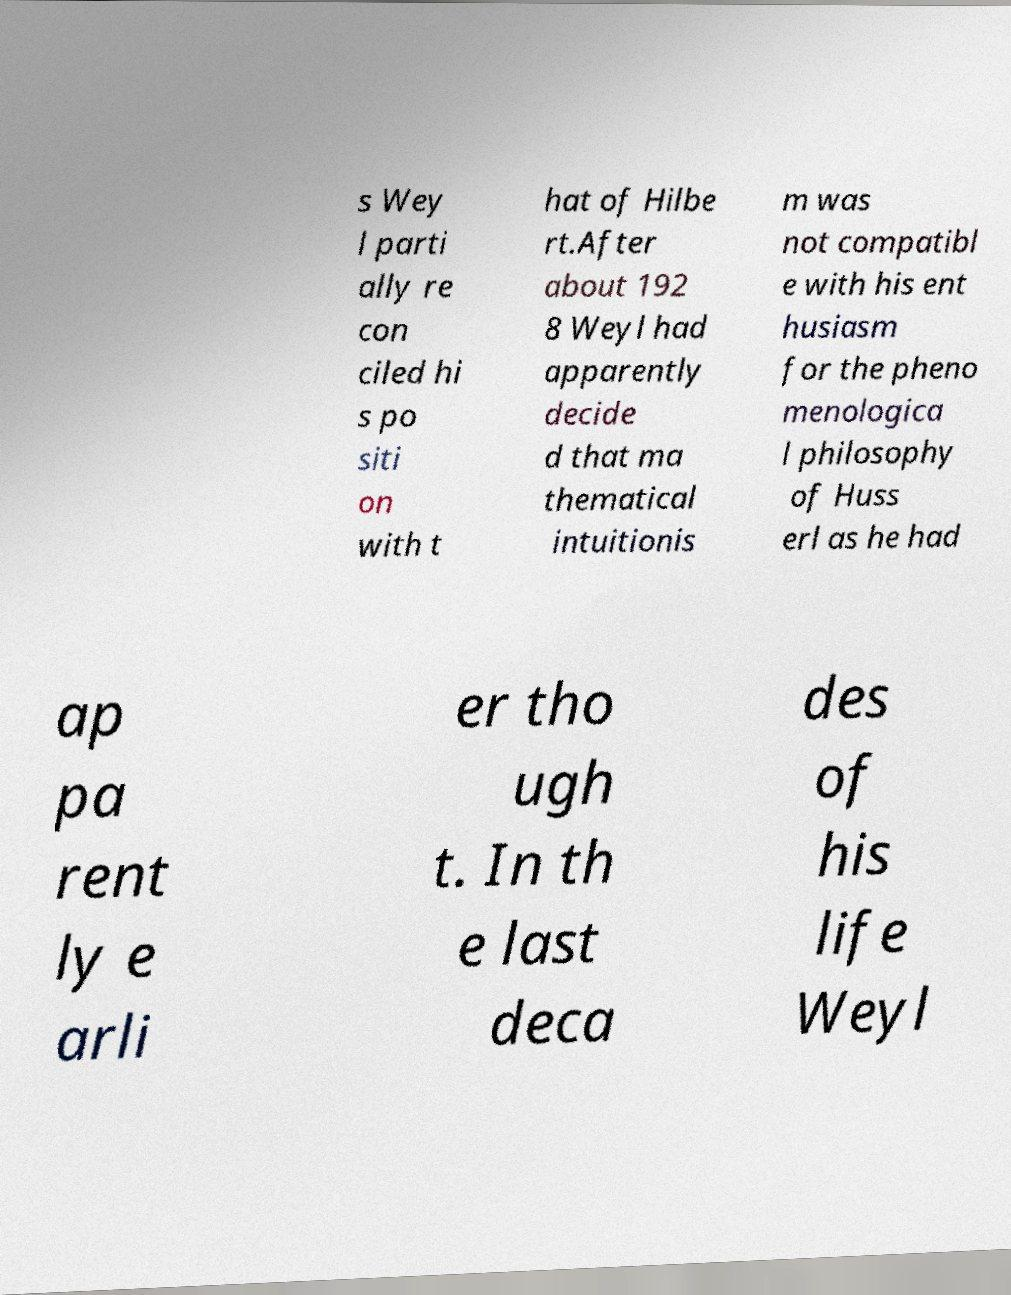Can you read and provide the text displayed in the image?This photo seems to have some interesting text. Can you extract and type it out for me? s Wey l parti ally re con ciled hi s po siti on with t hat of Hilbe rt.After about 192 8 Weyl had apparently decide d that ma thematical intuitionis m was not compatibl e with his ent husiasm for the pheno menologica l philosophy of Huss erl as he had ap pa rent ly e arli er tho ugh t. In th e last deca des of his life Weyl 